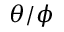<formula> <loc_0><loc_0><loc_500><loc_500>\theta / \phi</formula> 